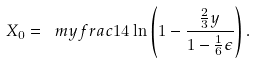<formula> <loc_0><loc_0><loc_500><loc_500>X _ { 0 } = \ m y f r a c 1 4 \ln \left ( 1 - \frac { \frac { 2 } { 3 } y } { 1 - \frac { 1 } { 6 } \epsilon } \right ) .</formula> 